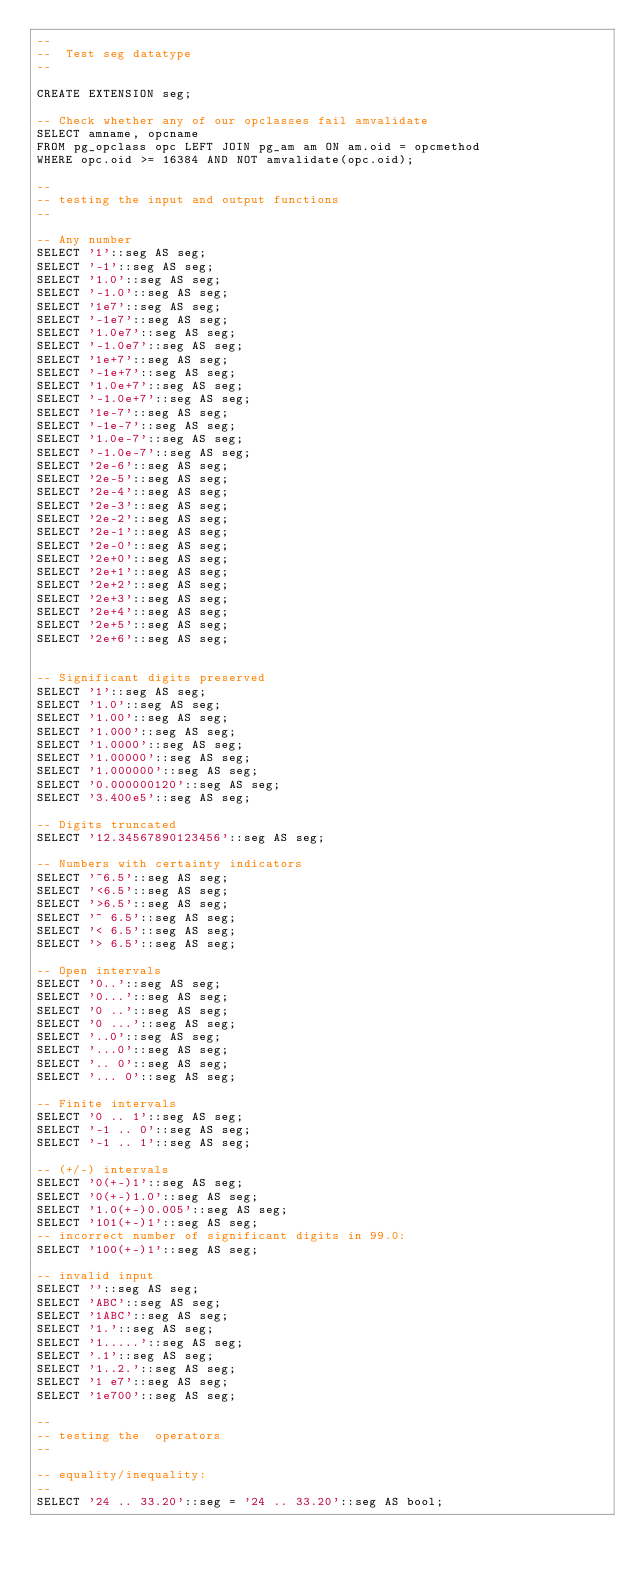Convert code to text. <code><loc_0><loc_0><loc_500><loc_500><_SQL_>--
--  Test seg datatype
--

CREATE EXTENSION seg;

-- Check whether any of our opclasses fail amvalidate
SELECT amname, opcname
FROM pg_opclass opc LEFT JOIN pg_am am ON am.oid = opcmethod
WHERE opc.oid >= 16384 AND NOT amvalidate(opc.oid);

--
-- testing the input and output functions
--

-- Any number
SELECT '1'::seg AS seg;
SELECT '-1'::seg AS seg;
SELECT '1.0'::seg AS seg;
SELECT '-1.0'::seg AS seg;
SELECT '1e7'::seg AS seg;
SELECT '-1e7'::seg AS seg;
SELECT '1.0e7'::seg AS seg;
SELECT '-1.0e7'::seg AS seg;
SELECT '1e+7'::seg AS seg;
SELECT '-1e+7'::seg AS seg;
SELECT '1.0e+7'::seg AS seg;
SELECT '-1.0e+7'::seg AS seg;
SELECT '1e-7'::seg AS seg;
SELECT '-1e-7'::seg AS seg;
SELECT '1.0e-7'::seg AS seg;
SELECT '-1.0e-7'::seg AS seg;
SELECT '2e-6'::seg AS seg;
SELECT '2e-5'::seg AS seg;
SELECT '2e-4'::seg AS seg;
SELECT '2e-3'::seg AS seg;
SELECT '2e-2'::seg AS seg;
SELECT '2e-1'::seg AS seg;
SELECT '2e-0'::seg AS seg;
SELECT '2e+0'::seg AS seg;
SELECT '2e+1'::seg AS seg;
SELECT '2e+2'::seg AS seg;
SELECT '2e+3'::seg AS seg;
SELECT '2e+4'::seg AS seg;
SELECT '2e+5'::seg AS seg;
SELECT '2e+6'::seg AS seg;


-- Significant digits preserved
SELECT '1'::seg AS seg;
SELECT '1.0'::seg AS seg;
SELECT '1.00'::seg AS seg;
SELECT '1.000'::seg AS seg;
SELECT '1.0000'::seg AS seg;
SELECT '1.00000'::seg AS seg;
SELECT '1.000000'::seg AS seg;
SELECT '0.000000120'::seg AS seg;
SELECT '3.400e5'::seg AS seg;

-- Digits truncated
SELECT '12.34567890123456'::seg AS seg;

-- Numbers with certainty indicators
SELECT '~6.5'::seg AS seg;
SELECT '<6.5'::seg AS seg;
SELECT '>6.5'::seg AS seg;
SELECT '~ 6.5'::seg AS seg;
SELECT '< 6.5'::seg AS seg;
SELECT '> 6.5'::seg AS seg;

-- Open intervals
SELECT '0..'::seg AS seg;
SELECT '0...'::seg AS seg;
SELECT '0 ..'::seg AS seg;
SELECT '0 ...'::seg AS seg;
SELECT '..0'::seg AS seg;
SELECT '...0'::seg AS seg;
SELECT '.. 0'::seg AS seg;
SELECT '... 0'::seg AS seg;

-- Finite intervals
SELECT '0 .. 1'::seg AS seg;
SELECT '-1 .. 0'::seg AS seg;
SELECT '-1 .. 1'::seg AS seg;

-- (+/-) intervals
SELECT '0(+-)1'::seg AS seg;
SELECT '0(+-)1.0'::seg AS seg;
SELECT '1.0(+-)0.005'::seg AS seg;
SELECT '101(+-)1'::seg AS seg;
-- incorrect number of significant digits in 99.0:
SELECT '100(+-)1'::seg AS seg;

-- invalid input
SELECT ''::seg AS seg;
SELECT 'ABC'::seg AS seg;
SELECT '1ABC'::seg AS seg;
SELECT '1.'::seg AS seg;
SELECT '1.....'::seg AS seg;
SELECT '.1'::seg AS seg;
SELECT '1..2.'::seg AS seg;
SELECT '1 e7'::seg AS seg;
SELECT '1e700'::seg AS seg;

--
-- testing the  operators
--

-- equality/inequality:
--
SELECT '24 .. 33.20'::seg = '24 .. 33.20'::seg AS bool;</code> 